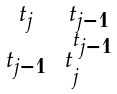<formula> <loc_0><loc_0><loc_500><loc_500>\begin{smallmatrix} t _ { j } & & t _ { j - 1 } \\ t _ { j - 1 } & & t _ { j } ^ { t _ { j - 1 } } \end{smallmatrix}</formula> 